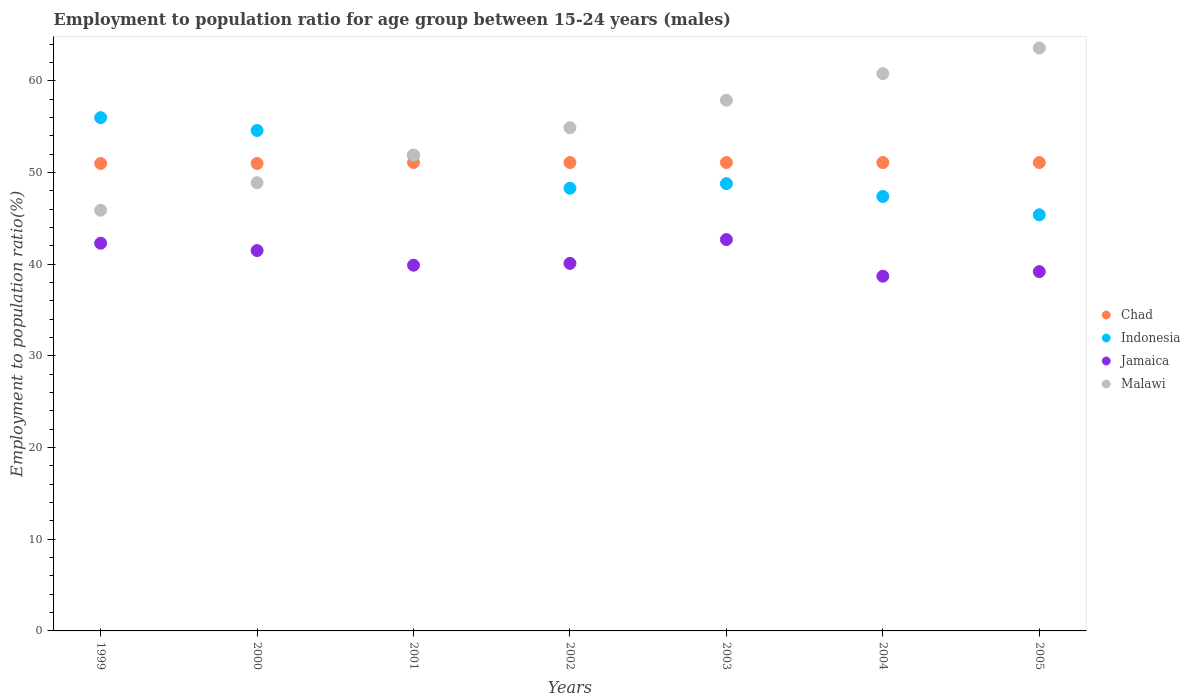How many different coloured dotlines are there?
Ensure brevity in your answer.  4. Is the number of dotlines equal to the number of legend labels?
Provide a short and direct response. Yes. What is the employment to population ratio in Jamaica in 2002?
Offer a very short reply. 40.1. Across all years, what is the maximum employment to population ratio in Malawi?
Offer a very short reply. 63.6. Across all years, what is the minimum employment to population ratio in Malawi?
Your response must be concise. 45.9. In which year was the employment to population ratio in Indonesia maximum?
Offer a terse response. 1999. In which year was the employment to population ratio in Chad minimum?
Make the answer very short. 1999. What is the total employment to population ratio in Malawi in the graph?
Make the answer very short. 383.9. What is the difference between the employment to population ratio in Indonesia in 2003 and that in 2004?
Give a very brief answer. 1.4. What is the difference between the employment to population ratio in Chad in 2002 and the employment to population ratio in Indonesia in 2001?
Ensure brevity in your answer.  -0.8. What is the average employment to population ratio in Jamaica per year?
Offer a very short reply. 40.63. In the year 2001, what is the difference between the employment to population ratio in Chad and employment to population ratio in Malawi?
Give a very brief answer. -0.8. What is the ratio of the employment to population ratio in Jamaica in 2000 to that in 2001?
Make the answer very short. 1.04. Is the employment to population ratio in Chad in 2003 less than that in 2004?
Your response must be concise. No. Is the difference between the employment to population ratio in Chad in 1999 and 2003 greater than the difference between the employment to population ratio in Malawi in 1999 and 2003?
Your answer should be compact. Yes. What is the difference between the highest and the second highest employment to population ratio in Malawi?
Your answer should be very brief. 2.8. What is the difference between the highest and the lowest employment to population ratio in Indonesia?
Make the answer very short. 10.6. In how many years, is the employment to population ratio in Jamaica greater than the average employment to population ratio in Jamaica taken over all years?
Keep it short and to the point. 3. Is the sum of the employment to population ratio in Malawi in 1999 and 2001 greater than the maximum employment to population ratio in Indonesia across all years?
Offer a terse response. Yes. Is it the case that in every year, the sum of the employment to population ratio in Chad and employment to population ratio in Jamaica  is greater than the sum of employment to population ratio in Malawi and employment to population ratio in Indonesia?
Your answer should be compact. No. Is it the case that in every year, the sum of the employment to population ratio in Chad and employment to population ratio in Jamaica  is greater than the employment to population ratio in Malawi?
Ensure brevity in your answer.  Yes. Is the employment to population ratio in Malawi strictly greater than the employment to population ratio in Jamaica over the years?
Offer a very short reply. Yes. Is the employment to population ratio in Chad strictly less than the employment to population ratio in Jamaica over the years?
Make the answer very short. No. How many dotlines are there?
Your answer should be very brief. 4. What is the difference between two consecutive major ticks on the Y-axis?
Your response must be concise. 10. Does the graph contain any zero values?
Provide a short and direct response. No. Does the graph contain grids?
Provide a short and direct response. No. How many legend labels are there?
Your answer should be compact. 4. How are the legend labels stacked?
Provide a short and direct response. Vertical. What is the title of the graph?
Your answer should be very brief. Employment to population ratio for age group between 15-24 years (males). Does "Central Europe" appear as one of the legend labels in the graph?
Your answer should be compact. No. What is the Employment to population ratio(%) in Chad in 1999?
Keep it short and to the point. 51. What is the Employment to population ratio(%) of Jamaica in 1999?
Offer a terse response. 42.3. What is the Employment to population ratio(%) of Malawi in 1999?
Offer a very short reply. 45.9. What is the Employment to population ratio(%) of Indonesia in 2000?
Offer a very short reply. 54.6. What is the Employment to population ratio(%) of Jamaica in 2000?
Offer a very short reply. 41.5. What is the Employment to population ratio(%) in Malawi in 2000?
Your answer should be compact. 48.9. What is the Employment to population ratio(%) in Chad in 2001?
Provide a succinct answer. 51.1. What is the Employment to population ratio(%) of Indonesia in 2001?
Your answer should be compact. 51.9. What is the Employment to population ratio(%) in Jamaica in 2001?
Offer a very short reply. 39.9. What is the Employment to population ratio(%) in Malawi in 2001?
Provide a succinct answer. 51.9. What is the Employment to population ratio(%) in Chad in 2002?
Provide a succinct answer. 51.1. What is the Employment to population ratio(%) in Indonesia in 2002?
Give a very brief answer. 48.3. What is the Employment to population ratio(%) in Jamaica in 2002?
Offer a terse response. 40.1. What is the Employment to population ratio(%) of Malawi in 2002?
Your response must be concise. 54.9. What is the Employment to population ratio(%) in Chad in 2003?
Give a very brief answer. 51.1. What is the Employment to population ratio(%) in Indonesia in 2003?
Your answer should be very brief. 48.8. What is the Employment to population ratio(%) in Jamaica in 2003?
Your response must be concise. 42.7. What is the Employment to population ratio(%) in Malawi in 2003?
Your answer should be very brief. 57.9. What is the Employment to population ratio(%) of Chad in 2004?
Your answer should be very brief. 51.1. What is the Employment to population ratio(%) in Indonesia in 2004?
Give a very brief answer. 47.4. What is the Employment to population ratio(%) of Jamaica in 2004?
Keep it short and to the point. 38.7. What is the Employment to population ratio(%) in Malawi in 2004?
Provide a succinct answer. 60.8. What is the Employment to population ratio(%) of Chad in 2005?
Provide a succinct answer. 51.1. What is the Employment to population ratio(%) of Indonesia in 2005?
Offer a very short reply. 45.4. What is the Employment to population ratio(%) in Jamaica in 2005?
Offer a very short reply. 39.2. What is the Employment to population ratio(%) in Malawi in 2005?
Provide a short and direct response. 63.6. Across all years, what is the maximum Employment to population ratio(%) of Chad?
Your answer should be compact. 51.1. Across all years, what is the maximum Employment to population ratio(%) of Jamaica?
Offer a terse response. 42.7. Across all years, what is the maximum Employment to population ratio(%) in Malawi?
Your answer should be compact. 63.6. Across all years, what is the minimum Employment to population ratio(%) of Indonesia?
Keep it short and to the point. 45.4. Across all years, what is the minimum Employment to population ratio(%) in Jamaica?
Provide a succinct answer. 38.7. Across all years, what is the minimum Employment to population ratio(%) of Malawi?
Provide a short and direct response. 45.9. What is the total Employment to population ratio(%) of Chad in the graph?
Give a very brief answer. 357.5. What is the total Employment to population ratio(%) in Indonesia in the graph?
Give a very brief answer. 352.4. What is the total Employment to population ratio(%) of Jamaica in the graph?
Ensure brevity in your answer.  284.4. What is the total Employment to population ratio(%) of Malawi in the graph?
Make the answer very short. 383.9. What is the difference between the Employment to population ratio(%) of Chad in 1999 and that in 2000?
Your answer should be compact. 0. What is the difference between the Employment to population ratio(%) of Indonesia in 1999 and that in 2000?
Your answer should be very brief. 1.4. What is the difference between the Employment to population ratio(%) of Jamaica in 1999 and that in 2000?
Offer a terse response. 0.8. What is the difference between the Employment to population ratio(%) in Malawi in 1999 and that in 2000?
Offer a terse response. -3. What is the difference between the Employment to population ratio(%) in Chad in 1999 and that in 2001?
Provide a succinct answer. -0.1. What is the difference between the Employment to population ratio(%) of Chad in 1999 and that in 2002?
Give a very brief answer. -0.1. What is the difference between the Employment to population ratio(%) in Indonesia in 1999 and that in 2002?
Provide a succinct answer. 7.7. What is the difference between the Employment to population ratio(%) in Jamaica in 1999 and that in 2002?
Your response must be concise. 2.2. What is the difference between the Employment to population ratio(%) of Malawi in 1999 and that in 2002?
Give a very brief answer. -9. What is the difference between the Employment to population ratio(%) in Malawi in 1999 and that in 2003?
Keep it short and to the point. -12. What is the difference between the Employment to population ratio(%) of Chad in 1999 and that in 2004?
Keep it short and to the point. -0.1. What is the difference between the Employment to population ratio(%) in Indonesia in 1999 and that in 2004?
Provide a short and direct response. 8.6. What is the difference between the Employment to population ratio(%) in Malawi in 1999 and that in 2004?
Your response must be concise. -14.9. What is the difference between the Employment to population ratio(%) in Jamaica in 1999 and that in 2005?
Give a very brief answer. 3.1. What is the difference between the Employment to population ratio(%) in Malawi in 1999 and that in 2005?
Your response must be concise. -17.7. What is the difference between the Employment to population ratio(%) of Indonesia in 2000 and that in 2001?
Offer a very short reply. 2.7. What is the difference between the Employment to population ratio(%) of Chad in 2000 and that in 2002?
Provide a succinct answer. -0.1. What is the difference between the Employment to population ratio(%) in Indonesia in 2000 and that in 2002?
Give a very brief answer. 6.3. What is the difference between the Employment to population ratio(%) in Jamaica in 2000 and that in 2002?
Provide a succinct answer. 1.4. What is the difference between the Employment to population ratio(%) in Malawi in 2000 and that in 2002?
Your response must be concise. -6. What is the difference between the Employment to population ratio(%) of Chad in 2000 and that in 2003?
Provide a succinct answer. -0.1. What is the difference between the Employment to population ratio(%) in Indonesia in 2000 and that in 2003?
Provide a short and direct response. 5.8. What is the difference between the Employment to population ratio(%) in Jamaica in 2000 and that in 2003?
Offer a terse response. -1.2. What is the difference between the Employment to population ratio(%) in Jamaica in 2000 and that in 2004?
Your answer should be compact. 2.8. What is the difference between the Employment to population ratio(%) of Malawi in 2000 and that in 2004?
Keep it short and to the point. -11.9. What is the difference between the Employment to population ratio(%) of Chad in 2000 and that in 2005?
Provide a succinct answer. -0.1. What is the difference between the Employment to population ratio(%) of Indonesia in 2000 and that in 2005?
Make the answer very short. 9.2. What is the difference between the Employment to population ratio(%) of Jamaica in 2000 and that in 2005?
Your response must be concise. 2.3. What is the difference between the Employment to population ratio(%) in Malawi in 2000 and that in 2005?
Keep it short and to the point. -14.7. What is the difference between the Employment to population ratio(%) in Malawi in 2001 and that in 2002?
Ensure brevity in your answer.  -3. What is the difference between the Employment to population ratio(%) in Chad in 2001 and that in 2003?
Your answer should be very brief. 0. What is the difference between the Employment to population ratio(%) of Malawi in 2001 and that in 2003?
Ensure brevity in your answer.  -6. What is the difference between the Employment to population ratio(%) in Chad in 2001 and that in 2004?
Give a very brief answer. 0. What is the difference between the Employment to population ratio(%) in Jamaica in 2001 and that in 2004?
Your response must be concise. 1.2. What is the difference between the Employment to population ratio(%) of Chad in 2001 and that in 2005?
Provide a short and direct response. 0. What is the difference between the Employment to population ratio(%) of Jamaica in 2001 and that in 2005?
Keep it short and to the point. 0.7. What is the difference between the Employment to population ratio(%) of Malawi in 2001 and that in 2005?
Your response must be concise. -11.7. What is the difference between the Employment to population ratio(%) in Chad in 2002 and that in 2003?
Give a very brief answer. 0. What is the difference between the Employment to population ratio(%) of Indonesia in 2002 and that in 2003?
Your response must be concise. -0.5. What is the difference between the Employment to population ratio(%) in Jamaica in 2002 and that in 2003?
Ensure brevity in your answer.  -2.6. What is the difference between the Employment to population ratio(%) of Jamaica in 2002 and that in 2004?
Offer a terse response. 1.4. What is the difference between the Employment to population ratio(%) of Malawi in 2002 and that in 2004?
Make the answer very short. -5.9. What is the difference between the Employment to population ratio(%) of Indonesia in 2002 and that in 2005?
Offer a terse response. 2.9. What is the difference between the Employment to population ratio(%) of Jamaica in 2002 and that in 2005?
Make the answer very short. 0.9. What is the difference between the Employment to population ratio(%) in Malawi in 2002 and that in 2005?
Provide a succinct answer. -8.7. What is the difference between the Employment to population ratio(%) of Chad in 2003 and that in 2004?
Provide a succinct answer. 0. What is the difference between the Employment to population ratio(%) of Malawi in 2003 and that in 2004?
Provide a short and direct response. -2.9. What is the difference between the Employment to population ratio(%) in Chad in 2003 and that in 2005?
Offer a terse response. 0. What is the difference between the Employment to population ratio(%) in Malawi in 2003 and that in 2005?
Your answer should be very brief. -5.7. What is the difference between the Employment to population ratio(%) in Chad in 2004 and that in 2005?
Provide a short and direct response. 0. What is the difference between the Employment to population ratio(%) in Indonesia in 2004 and that in 2005?
Give a very brief answer. 2. What is the difference between the Employment to population ratio(%) of Jamaica in 2004 and that in 2005?
Offer a very short reply. -0.5. What is the difference between the Employment to population ratio(%) in Chad in 1999 and the Employment to population ratio(%) in Indonesia in 2000?
Make the answer very short. -3.6. What is the difference between the Employment to population ratio(%) in Chad in 1999 and the Employment to population ratio(%) in Jamaica in 2000?
Your answer should be compact. 9.5. What is the difference between the Employment to population ratio(%) in Chad in 1999 and the Employment to population ratio(%) in Indonesia in 2001?
Make the answer very short. -0.9. What is the difference between the Employment to population ratio(%) of Chad in 1999 and the Employment to population ratio(%) of Jamaica in 2001?
Provide a succinct answer. 11.1. What is the difference between the Employment to population ratio(%) in Chad in 1999 and the Employment to population ratio(%) in Malawi in 2001?
Your answer should be compact. -0.9. What is the difference between the Employment to population ratio(%) of Indonesia in 1999 and the Employment to population ratio(%) of Jamaica in 2001?
Ensure brevity in your answer.  16.1. What is the difference between the Employment to population ratio(%) in Jamaica in 1999 and the Employment to population ratio(%) in Malawi in 2001?
Make the answer very short. -9.6. What is the difference between the Employment to population ratio(%) in Chad in 1999 and the Employment to population ratio(%) in Malawi in 2002?
Keep it short and to the point. -3.9. What is the difference between the Employment to population ratio(%) in Indonesia in 1999 and the Employment to population ratio(%) in Malawi in 2002?
Ensure brevity in your answer.  1.1. What is the difference between the Employment to population ratio(%) of Jamaica in 1999 and the Employment to population ratio(%) of Malawi in 2002?
Your answer should be very brief. -12.6. What is the difference between the Employment to population ratio(%) in Chad in 1999 and the Employment to population ratio(%) in Indonesia in 2003?
Keep it short and to the point. 2.2. What is the difference between the Employment to population ratio(%) of Chad in 1999 and the Employment to population ratio(%) of Malawi in 2003?
Ensure brevity in your answer.  -6.9. What is the difference between the Employment to population ratio(%) of Indonesia in 1999 and the Employment to population ratio(%) of Malawi in 2003?
Offer a terse response. -1.9. What is the difference between the Employment to population ratio(%) of Jamaica in 1999 and the Employment to population ratio(%) of Malawi in 2003?
Ensure brevity in your answer.  -15.6. What is the difference between the Employment to population ratio(%) of Chad in 1999 and the Employment to population ratio(%) of Indonesia in 2004?
Offer a terse response. 3.6. What is the difference between the Employment to population ratio(%) in Chad in 1999 and the Employment to population ratio(%) in Jamaica in 2004?
Your response must be concise. 12.3. What is the difference between the Employment to population ratio(%) of Chad in 1999 and the Employment to population ratio(%) of Malawi in 2004?
Your answer should be very brief. -9.8. What is the difference between the Employment to population ratio(%) of Indonesia in 1999 and the Employment to population ratio(%) of Jamaica in 2004?
Provide a succinct answer. 17.3. What is the difference between the Employment to population ratio(%) of Indonesia in 1999 and the Employment to population ratio(%) of Malawi in 2004?
Offer a very short reply. -4.8. What is the difference between the Employment to population ratio(%) of Jamaica in 1999 and the Employment to population ratio(%) of Malawi in 2004?
Offer a terse response. -18.5. What is the difference between the Employment to population ratio(%) in Chad in 1999 and the Employment to population ratio(%) in Jamaica in 2005?
Provide a succinct answer. 11.8. What is the difference between the Employment to population ratio(%) of Indonesia in 1999 and the Employment to population ratio(%) of Jamaica in 2005?
Give a very brief answer. 16.8. What is the difference between the Employment to population ratio(%) in Jamaica in 1999 and the Employment to population ratio(%) in Malawi in 2005?
Your answer should be compact. -21.3. What is the difference between the Employment to population ratio(%) in Chad in 2000 and the Employment to population ratio(%) in Indonesia in 2001?
Ensure brevity in your answer.  -0.9. What is the difference between the Employment to population ratio(%) in Chad in 2000 and the Employment to population ratio(%) in Jamaica in 2001?
Ensure brevity in your answer.  11.1. What is the difference between the Employment to population ratio(%) of Indonesia in 2000 and the Employment to population ratio(%) of Jamaica in 2001?
Keep it short and to the point. 14.7. What is the difference between the Employment to population ratio(%) in Indonesia in 2000 and the Employment to population ratio(%) in Malawi in 2001?
Your response must be concise. 2.7. What is the difference between the Employment to population ratio(%) of Chad in 2000 and the Employment to population ratio(%) of Malawi in 2002?
Provide a succinct answer. -3.9. What is the difference between the Employment to population ratio(%) of Indonesia in 2000 and the Employment to population ratio(%) of Jamaica in 2002?
Provide a short and direct response. 14.5. What is the difference between the Employment to population ratio(%) in Jamaica in 2000 and the Employment to population ratio(%) in Malawi in 2002?
Offer a terse response. -13.4. What is the difference between the Employment to population ratio(%) in Chad in 2000 and the Employment to population ratio(%) in Jamaica in 2003?
Provide a short and direct response. 8.3. What is the difference between the Employment to population ratio(%) of Chad in 2000 and the Employment to population ratio(%) of Malawi in 2003?
Your answer should be compact. -6.9. What is the difference between the Employment to population ratio(%) of Indonesia in 2000 and the Employment to population ratio(%) of Malawi in 2003?
Your response must be concise. -3.3. What is the difference between the Employment to population ratio(%) in Jamaica in 2000 and the Employment to population ratio(%) in Malawi in 2003?
Ensure brevity in your answer.  -16.4. What is the difference between the Employment to population ratio(%) in Chad in 2000 and the Employment to population ratio(%) in Jamaica in 2004?
Provide a short and direct response. 12.3. What is the difference between the Employment to population ratio(%) of Jamaica in 2000 and the Employment to population ratio(%) of Malawi in 2004?
Your answer should be compact. -19.3. What is the difference between the Employment to population ratio(%) in Chad in 2000 and the Employment to population ratio(%) in Jamaica in 2005?
Keep it short and to the point. 11.8. What is the difference between the Employment to population ratio(%) of Chad in 2000 and the Employment to population ratio(%) of Malawi in 2005?
Your response must be concise. -12.6. What is the difference between the Employment to population ratio(%) of Indonesia in 2000 and the Employment to population ratio(%) of Malawi in 2005?
Your answer should be very brief. -9. What is the difference between the Employment to population ratio(%) in Jamaica in 2000 and the Employment to population ratio(%) in Malawi in 2005?
Ensure brevity in your answer.  -22.1. What is the difference between the Employment to population ratio(%) in Chad in 2001 and the Employment to population ratio(%) in Indonesia in 2002?
Offer a terse response. 2.8. What is the difference between the Employment to population ratio(%) of Indonesia in 2001 and the Employment to population ratio(%) of Jamaica in 2002?
Your answer should be compact. 11.8. What is the difference between the Employment to population ratio(%) in Indonesia in 2001 and the Employment to population ratio(%) in Malawi in 2002?
Provide a short and direct response. -3. What is the difference between the Employment to population ratio(%) in Jamaica in 2001 and the Employment to population ratio(%) in Malawi in 2002?
Provide a succinct answer. -15. What is the difference between the Employment to population ratio(%) in Chad in 2001 and the Employment to population ratio(%) in Jamaica in 2003?
Your answer should be compact. 8.4. What is the difference between the Employment to population ratio(%) in Indonesia in 2001 and the Employment to population ratio(%) in Malawi in 2003?
Offer a very short reply. -6. What is the difference between the Employment to population ratio(%) of Jamaica in 2001 and the Employment to population ratio(%) of Malawi in 2003?
Give a very brief answer. -18. What is the difference between the Employment to population ratio(%) of Chad in 2001 and the Employment to population ratio(%) of Malawi in 2004?
Make the answer very short. -9.7. What is the difference between the Employment to population ratio(%) in Indonesia in 2001 and the Employment to population ratio(%) in Jamaica in 2004?
Your response must be concise. 13.2. What is the difference between the Employment to population ratio(%) of Jamaica in 2001 and the Employment to population ratio(%) of Malawi in 2004?
Provide a short and direct response. -20.9. What is the difference between the Employment to population ratio(%) in Indonesia in 2001 and the Employment to population ratio(%) in Malawi in 2005?
Provide a short and direct response. -11.7. What is the difference between the Employment to population ratio(%) in Jamaica in 2001 and the Employment to population ratio(%) in Malawi in 2005?
Ensure brevity in your answer.  -23.7. What is the difference between the Employment to population ratio(%) of Chad in 2002 and the Employment to population ratio(%) of Jamaica in 2003?
Make the answer very short. 8.4. What is the difference between the Employment to population ratio(%) in Chad in 2002 and the Employment to population ratio(%) in Malawi in 2003?
Give a very brief answer. -6.8. What is the difference between the Employment to population ratio(%) in Indonesia in 2002 and the Employment to population ratio(%) in Malawi in 2003?
Offer a very short reply. -9.6. What is the difference between the Employment to population ratio(%) of Jamaica in 2002 and the Employment to population ratio(%) of Malawi in 2003?
Your response must be concise. -17.8. What is the difference between the Employment to population ratio(%) in Chad in 2002 and the Employment to population ratio(%) in Jamaica in 2004?
Keep it short and to the point. 12.4. What is the difference between the Employment to population ratio(%) in Jamaica in 2002 and the Employment to population ratio(%) in Malawi in 2004?
Your answer should be compact. -20.7. What is the difference between the Employment to population ratio(%) of Chad in 2002 and the Employment to population ratio(%) of Indonesia in 2005?
Keep it short and to the point. 5.7. What is the difference between the Employment to population ratio(%) in Chad in 2002 and the Employment to population ratio(%) in Jamaica in 2005?
Provide a succinct answer. 11.9. What is the difference between the Employment to population ratio(%) in Chad in 2002 and the Employment to population ratio(%) in Malawi in 2005?
Your answer should be compact. -12.5. What is the difference between the Employment to population ratio(%) in Indonesia in 2002 and the Employment to population ratio(%) in Malawi in 2005?
Provide a succinct answer. -15.3. What is the difference between the Employment to population ratio(%) in Jamaica in 2002 and the Employment to population ratio(%) in Malawi in 2005?
Your answer should be very brief. -23.5. What is the difference between the Employment to population ratio(%) of Chad in 2003 and the Employment to population ratio(%) of Jamaica in 2004?
Offer a terse response. 12.4. What is the difference between the Employment to population ratio(%) in Indonesia in 2003 and the Employment to population ratio(%) in Jamaica in 2004?
Your response must be concise. 10.1. What is the difference between the Employment to population ratio(%) of Indonesia in 2003 and the Employment to population ratio(%) of Malawi in 2004?
Your answer should be very brief. -12. What is the difference between the Employment to population ratio(%) of Jamaica in 2003 and the Employment to population ratio(%) of Malawi in 2004?
Ensure brevity in your answer.  -18.1. What is the difference between the Employment to population ratio(%) in Chad in 2003 and the Employment to population ratio(%) in Malawi in 2005?
Keep it short and to the point. -12.5. What is the difference between the Employment to population ratio(%) in Indonesia in 2003 and the Employment to population ratio(%) in Malawi in 2005?
Ensure brevity in your answer.  -14.8. What is the difference between the Employment to population ratio(%) in Jamaica in 2003 and the Employment to population ratio(%) in Malawi in 2005?
Ensure brevity in your answer.  -20.9. What is the difference between the Employment to population ratio(%) of Indonesia in 2004 and the Employment to population ratio(%) of Malawi in 2005?
Provide a succinct answer. -16.2. What is the difference between the Employment to population ratio(%) in Jamaica in 2004 and the Employment to population ratio(%) in Malawi in 2005?
Offer a very short reply. -24.9. What is the average Employment to population ratio(%) of Chad per year?
Your answer should be compact. 51.07. What is the average Employment to population ratio(%) of Indonesia per year?
Keep it short and to the point. 50.34. What is the average Employment to population ratio(%) of Jamaica per year?
Make the answer very short. 40.63. What is the average Employment to population ratio(%) in Malawi per year?
Ensure brevity in your answer.  54.84. In the year 1999, what is the difference between the Employment to population ratio(%) of Chad and Employment to population ratio(%) of Indonesia?
Offer a very short reply. -5. In the year 1999, what is the difference between the Employment to population ratio(%) in Chad and Employment to population ratio(%) in Jamaica?
Your answer should be very brief. 8.7. In the year 1999, what is the difference between the Employment to population ratio(%) in Chad and Employment to population ratio(%) in Malawi?
Ensure brevity in your answer.  5.1. In the year 1999, what is the difference between the Employment to population ratio(%) of Indonesia and Employment to population ratio(%) of Jamaica?
Your answer should be very brief. 13.7. In the year 1999, what is the difference between the Employment to population ratio(%) of Jamaica and Employment to population ratio(%) of Malawi?
Provide a short and direct response. -3.6. In the year 2000, what is the difference between the Employment to population ratio(%) in Chad and Employment to population ratio(%) in Jamaica?
Offer a terse response. 9.5. In the year 2000, what is the difference between the Employment to population ratio(%) in Indonesia and Employment to population ratio(%) in Jamaica?
Your answer should be very brief. 13.1. In the year 2000, what is the difference between the Employment to population ratio(%) of Indonesia and Employment to population ratio(%) of Malawi?
Offer a terse response. 5.7. In the year 2000, what is the difference between the Employment to population ratio(%) in Jamaica and Employment to population ratio(%) in Malawi?
Provide a short and direct response. -7.4. In the year 2001, what is the difference between the Employment to population ratio(%) of Indonesia and Employment to population ratio(%) of Malawi?
Offer a very short reply. 0. In the year 2001, what is the difference between the Employment to population ratio(%) of Jamaica and Employment to population ratio(%) of Malawi?
Provide a short and direct response. -12. In the year 2002, what is the difference between the Employment to population ratio(%) of Jamaica and Employment to population ratio(%) of Malawi?
Make the answer very short. -14.8. In the year 2003, what is the difference between the Employment to population ratio(%) in Chad and Employment to population ratio(%) in Jamaica?
Offer a terse response. 8.4. In the year 2003, what is the difference between the Employment to population ratio(%) of Jamaica and Employment to population ratio(%) of Malawi?
Offer a very short reply. -15.2. In the year 2004, what is the difference between the Employment to population ratio(%) of Chad and Employment to population ratio(%) of Malawi?
Ensure brevity in your answer.  -9.7. In the year 2004, what is the difference between the Employment to population ratio(%) of Jamaica and Employment to population ratio(%) of Malawi?
Your answer should be compact. -22.1. In the year 2005, what is the difference between the Employment to population ratio(%) in Chad and Employment to population ratio(%) in Indonesia?
Your response must be concise. 5.7. In the year 2005, what is the difference between the Employment to population ratio(%) of Indonesia and Employment to population ratio(%) of Malawi?
Make the answer very short. -18.2. In the year 2005, what is the difference between the Employment to population ratio(%) in Jamaica and Employment to population ratio(%) in Malawi?
Make the answer very short. -24.4. What is the ratio of the Employment to population ratio(%) of Indonesia in 1999 to that in 2000?
Give a very brief answer. 1.03. What is the ratio of the Employment to population ratio(%) in Jamaica in 1999 to that in 2000?
Your response must be concise. 1.02. What is the ratio of the Employment to population ratio(%) of Malawi in 1999 to that in 2000?
Offer a terse response. 0.94. What is the ratio of the Employment to population ratio(%) of Chad in 1999 to that in 2001?
Your response must be concise. 1. What is the ratio of the Employment to population ratio(%) in Indonesia in 1999 to that in 2001?
Offer a very short reply. 1.08. What is the ratio of the Employment to population ratio(%) in Jamaica in 1999 to that in 2001?
Provide a short and direct response. 1.06. What is the ratio of the Employment to population ratio(%) of Malawi in 1999 to that in 2001?
Offer a very short reply. 0.88. What is the ratio of the Employment to population ratio(%) in Chad in 1999 to that in 2002?
Your response must be concise. 1. What is the ratio of the Employment to population ratio(%) of Indonesia in 1999 to that in 2002?
Your response must be concise. 1.16. What is the ratio of the Employment to population ratio(%) in Jamaica in 1999 to that in 2002?
Ensure brevity in your answer.  1.05. What is the ratio of the Employment to population ratio(%) of Malawi in 1999 to that in 2002?
Offer a terse response. 0.84. What is the ratio of the Employment to population ratio(%) in Indonesia in 1999 to that in 2003?
Provide a succinct answer. 1.15. What is the ratio of the Employment to population ratio(%) in Jamaica in 1999 to that in 2003?
Give a very brief answer. 0.99. What is the ratio of the Employment to population ratio(%) of Malawi in 1999 to that in 2003?
Make the answer very short. 0.79. What is the ratio of the Employment to population ratio(%) of Chad in 1999 to that in 2004?
Your answer should be very brief. 1. What is the ratio of the Employment to population ratio(%) of Indonesia in 1999 to that in 2004?
Give a very brief answer. 1.18. What is the ratio of the Employment to population ratio(%) in Jamaica in 1999 to that in 2004?
Provide a succinct answer. 1.09. What is the ratio of the Employment to population ratio(%) of Malawi in 1999 to that in 2004?
Make the answer very short. 0.75. What is the ratio of the Employment to population ratio(%) in Indonesia in 1999 to that in 2005?
Provide a short and direct response. 1.23. What is the ratio of the Employment to population ratio(%) of Jamaica in 1999 to that in 2005?
Keep it short and to the point. 1.08. What is the ratio of the Employment to population ratio(%) of Malawi in 1999 to that in 2005?
Offer a terse response. 0.72. What is the ratio of the Employment to population ratio(%) in Indonesia in 2000 to that in 2001?
Your answer should be compact. 1.05. What is the ratio of the Employment to population ratio(%) of Jamaica in 2000 to that in 2001?
Ensure brevity in your answer.  1.04. What is the ratio of the Employment to population ratio(%) of Malawi in 2000 to that in 2001?
Your answer should be very brief. 0.94. What is the ratio of the Employment to population ratio(%) of Chad in 2000 to that in 2002?
Your answer should be very brief. 1. What is the ratio of the Employment to population ratio(%) of Indonesia in 2000 to that in 2002?
Offer a very short reply. 1.13. What is the ratio of the Employment to population ratio(%) in Jamaica in 2000 to that in 2002?
Your response must be concise. 1.03. What is the ratio of the Employment to population ratio(%) of Malawi in 2000 to that in 2002?
Your response must be concise. 0.89. What is the ratio of the Employment to population ratio(%) of Chad in 2000 to that in 2003?
Ensure brevity in your answer.  1. What is the ratio of the Employment to population ratio(%) in Indonesia in 2000 to that in 2003?
Give a very brief answer. 1.12. What is the ratio of the Employment to population ratio(%) in Jamaica in 2000 to that in 2003?
Your response must be concise. 0.97. What is the ratio of the Employment to population ratio(%) in Malawi in 2000 to that in 2003?
Offer a very short reply. 0.84. What is the ratio of the Employment to population ratio(%) of Indonesia in 2000 to that in 2004?
Keep it short and to the point. 1.15. What is the ratio of the Employment to population ratio(%) in Jamaica in 2000 to that in 2004?
Keep it short and to the point. 1.07. What is the ratio of the Employment to population ratio(%) of Malawi in 2000 to that in 2004?
Your answer should be very brief. 0.8. What is the ratio of the Employment to population ratio(%) in Indonesia in 2000 to that in 2005?
Your answer should be very brief. 1.2. What is the ratio of the Employment to population ratio(%) in Jamaica in 2000 to that in 2005?
Your answer should be very brief. 1.06. What is the ratio of the Employment to population ratio(%) of Malawi in 2000 to that in 2005?
Offer a terse response. 0.77. What is the ratio of the Employment to population ratio(%) in Indonesia in 2001 to that in 2002?
Your answer should be compact. 1.07. What is the ratio of the Employment to population ratio(%) of Malawi in 2001 to that in 2002?
Your answer should be very brief. 0.95. What is the ratio of the Employment to population ratio(%) of Chad in 2001 to that in 2003?
Keep it short and to the point. 1. What is the ratio of the Employment to population ratio(%) of Indonesia in 2001 to that in 2003?
Keep it short and to the point. 1.06. What is the ratio of the Employment to population ratio(%) of Jamaica in 2001 to that in 2003?
Your response must be concise. 0.93. What is the ratio of the Employment to population ratio(%) in Malawi in 2001 to that in 2003?
Provide a succinct answer. 0.9. What is the ratio of the Employment to population ratio(%) in Indonesia in 2001 to that in 2004?
Offer a terse response. 1.09. What is the ratio of the Employment to population ratio(%) of Jamaica in 2001 to that in 2004?
Provide a short and direct response. 1.03. What is the ratio of the Employment to population ratio(%) of Malawi in 2001 to that in 2004?
Your answer should be compact. 0.85. What is the ratio of the Employment to population ratio(%) in Indonesia in 2001 to that in 2005?
Your answer should be very brief. 1.14. What is the ratio of the Employment to population ratio(%) in Jamaica in 2001 to that in 2005?
Provide a succinct answer. 1.02. What is the ratio of the Employment to population ratio(%) of Malawi in 2001 to that in 2005?
Provide a short and direct response. 0.82. What is the ratio of the Employment to population ratio(%) of Chad in 2002 to that in 2003?
Your response must be concise. 1. What is the ratio of the Employment to population ratio(%) of Jamaica in 2002 to that in 2003?
Your answer should be compact. 0.94. What is the ratio of the Employment to population ratio(%) in Malawi in 2002 to that in 2003?
Provide a short and direct response. 0.95. What is the ratio of the Employment to population ratio(%) of Jamaica in 2002 to that in 2004?
Give a very brief answer. 1.04. What is the ratio of the Employment to population ratio(%) in Malawi in 2002 to that in 2004?
Offer a terse response. 0.9. What is the ratio of the Employment to population ratio(%) in Indonesia in 2002 to that in 2005?
Ensure brevity in your answer.  1.06. What is the ratio of the Employment to population ratio(%) in Malawi in 2002 to that in 2005?
Your answer should be compact. 0.86. What is the ratio of the Employment to population ratio(%) of Indonesia in 2003 to that in 2004?
Your answer should be very brief. 1.03. What is the ratio of the Employment to population ratio(%) of Jamaica in 2003 to that in 2004?
Your answer should be very brief. 1.1. What is the ratio of the Employment to population ratio(%) of Malawi in 2003 to that in 2004?
Your answer should be very brief. 0.95. What is the ratio of the Employment to population ratio(%) of Chad in 2003 to that in 2005?
Your answer should be compact. 1. What is the ratio of the Employment to population ratio(%) of Indonesia in 2003 to that in 2005?
Provide a succinct answer. 1.07. What is the ratio of the Employment to population ratio(%) of Jamaica in 2003 to that in 2005?
Your answer should be very brief. 1.09. What is the ratio of the Employment to population ratio(%) of Malawi in 2003 to that in 2005?
Your answer should be compact. 0.91. What is the ratio of the Employment to population ratio(%) in Indonesia in 2004 to that in 2005?
Keep it short and to the point. 1.04. What is the ratio of the Employment to population ratio(%) of Jamaica in 2004 to that in 2005?
Provide a succinct answer. 0.99. What is the ratio of the Employment to population ratio(%) of Malawi in 2004 to that in 2005?
Your answer should be very brief. 0.96. What is the difference between the highest and the second highest Employment to population ratio(%) in Chad?
Your answer should be very brief. 0. What is the difference between the highest and the second highest Employment to population ratio(%) in Indonesia?
Provide a succinct answer. 1.4. What is the difference between the highest and the second highest Employment to population ratio(%) in Jamaica?
Keep it short and to the point. 0.4. What is the difference between the highest and the second highest Employment to population ratio(%) in Malawi?
Your answer should be compact. 2.8. What is the difference between the highest and the lowest Employment to population ratio(%) of Chad?
Provide a short and direct response. 0.1. What is the difference between the highest and the lowest Employment to population ratio(%) in Malawi?
Your answer should be compact. 17.7. 